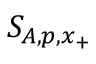<formula> <loc_0><loc_0><loc_500><loc_500>S _ { A , p , x _ { + } }</formula> 